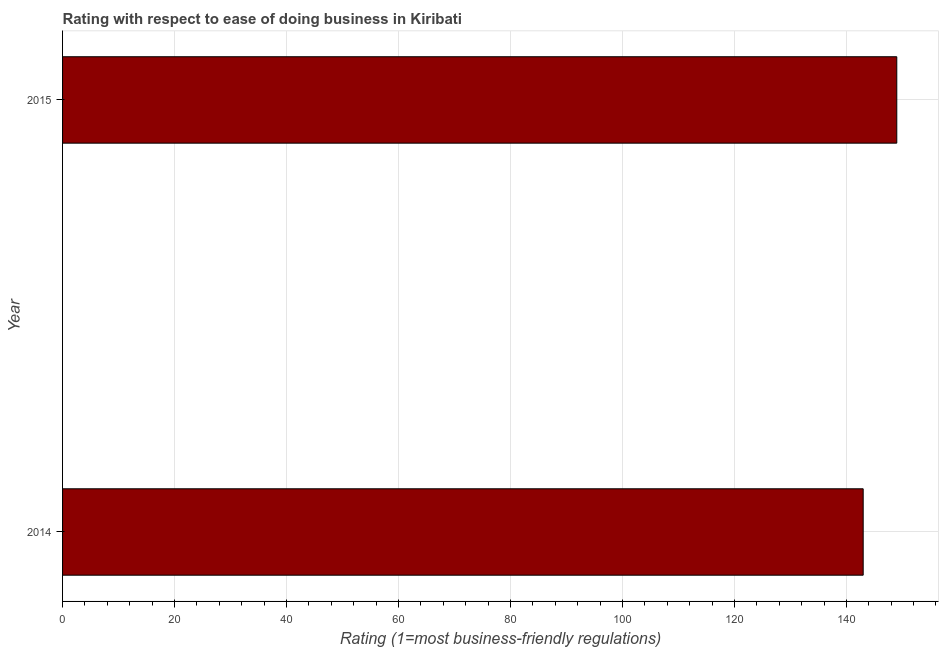Does the graph contain any zero values?
Ensure brevity in your answer.  No. Does the graph contain grids?
Give a very brief answer. Yes. What is the title of the graph?
Provide a succinct answer. Rating with respect to ease of doing business in Kiribati. What is the label or title of the X-axis?
Offer a terse response. Rating (1=most business-friendly regulations). What is the ease of doing business index in 2014?
Keep it short and to the point. 143. Across all years, what is the maximum ease of doing business index?
Provide a succinct answer. 149. Across all years, what is the minimum ease of doing business index?
Your answer should be very brief. 143. In which year was the ease of doing business index maximum?
Make the answer very short. 2015. What is the sum of the ease of doing business index?
Offer a very short reply. 292. What is the average ease of doing business index per year?
Offer a very short reply. 146. What is the median ease of doing business index?
Ensure brevity in your answer.  146. In how many years, is the ease of doing business index greater than the average ease of doing business index taken over all years?
Keep it short and to the point. 1. Are all the bars in the graph horizontal?
Keep it short and to the point. Yes. How many years are there in the graph?
Provide a short and direct response. 2. What is the difference between two consecutive major ticks on the X-axis?
Your answer should be compact. 20. What is the Rating (1=most business-friendly regulations) of 2014?
Your answer should be very brief. 143. What is the Rating (1=most business-friendly regulations) in 2015?
Keep it short and to the point. 149. What is the ratio of the Rating (1=most business-friendly regulations) in 2014 to that in 2015?
Offer a very short reply. 0.96. 